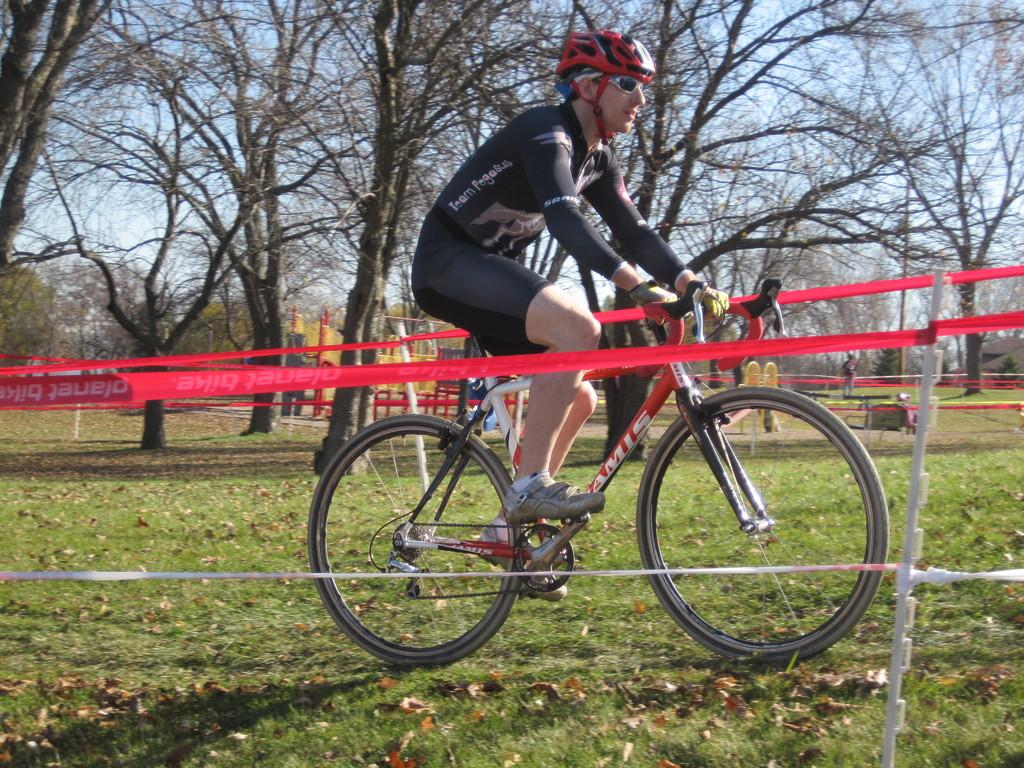What is the man in the image wearing on his head? The man is wearing a helmet in the image. What else is the man wearing for protection? The man is also wearing goggles in the image. What type of footwear is the man wearing? The man is wearing shoes in the image. What is the man doing in the image? The man is riding a bicycle in the image. What is the position of the bicycle in the image? The bicycle is on the ground in the image. What can be seen in the background of the image? There is a fence and trees in the background of the image. How many mice are running on the wheels of the bicycle in the image? There are no mice present in the image, and therefore no mice can be seen running on the wheels of the bicycle. 